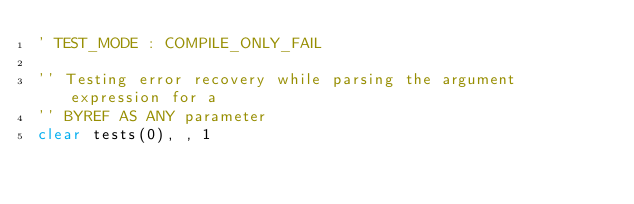<code> <loc_0><loc_0><loc_500><loc_500><_VisualBasic_>' TEST_MODE : COMPILE_ONLY_FAIL

'' Testing error recovery while parsing the argument expression for a
'' BYREF AS ANY parameter
clear tests(0), , 1
</code> 